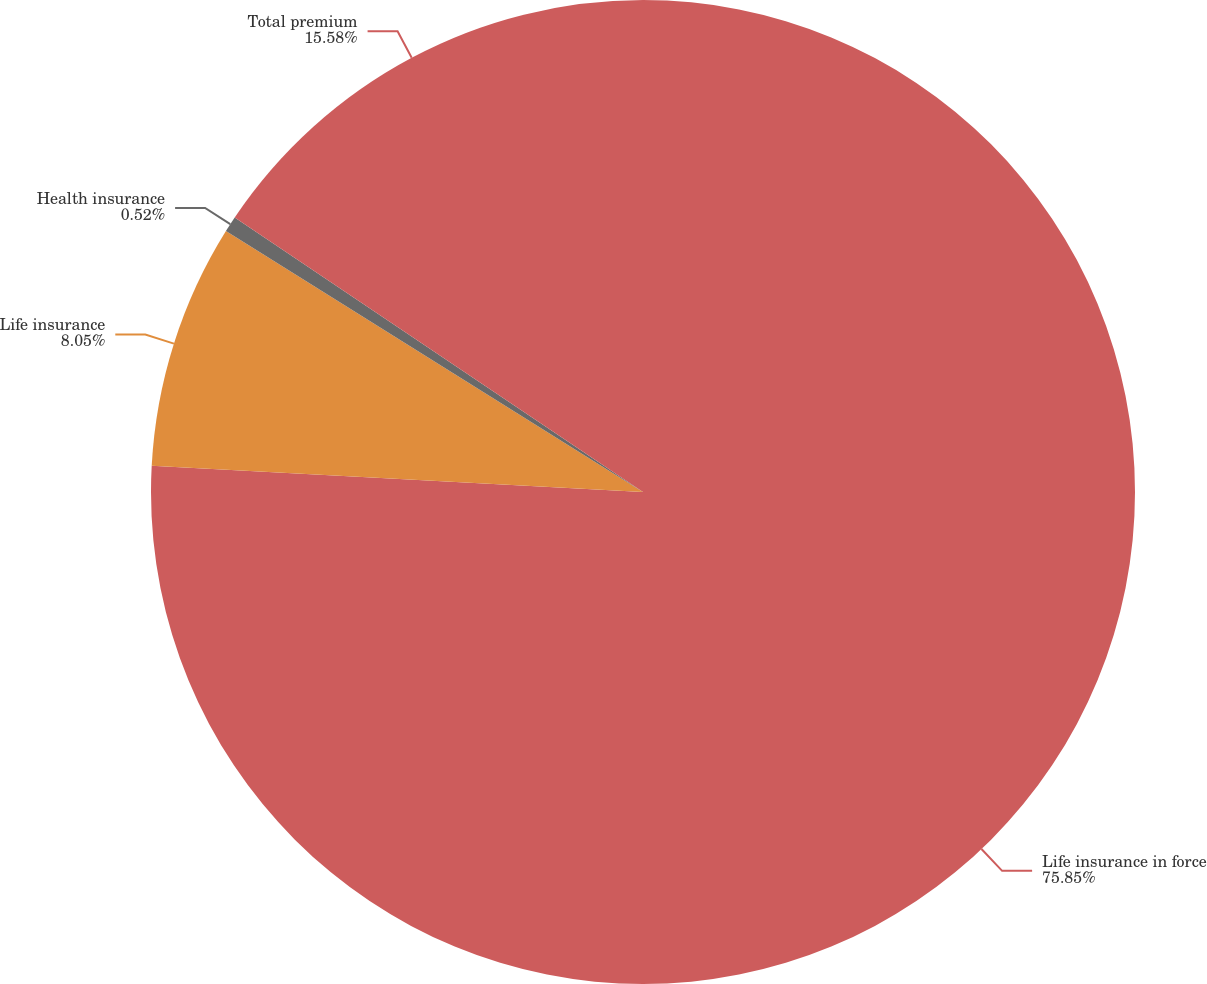Convert chart to OTSL. <chart><loc_0><loc_0><loc_500><loc_500><pie_chart><fcel>Life insurance in force<fcel>Life insurance<fcel>Health insurance<fcel>Total premium<nl><fcel>75.85%<fcel>8.05%<fcel>0.52%<fcel>15.58%<nl></chart> 